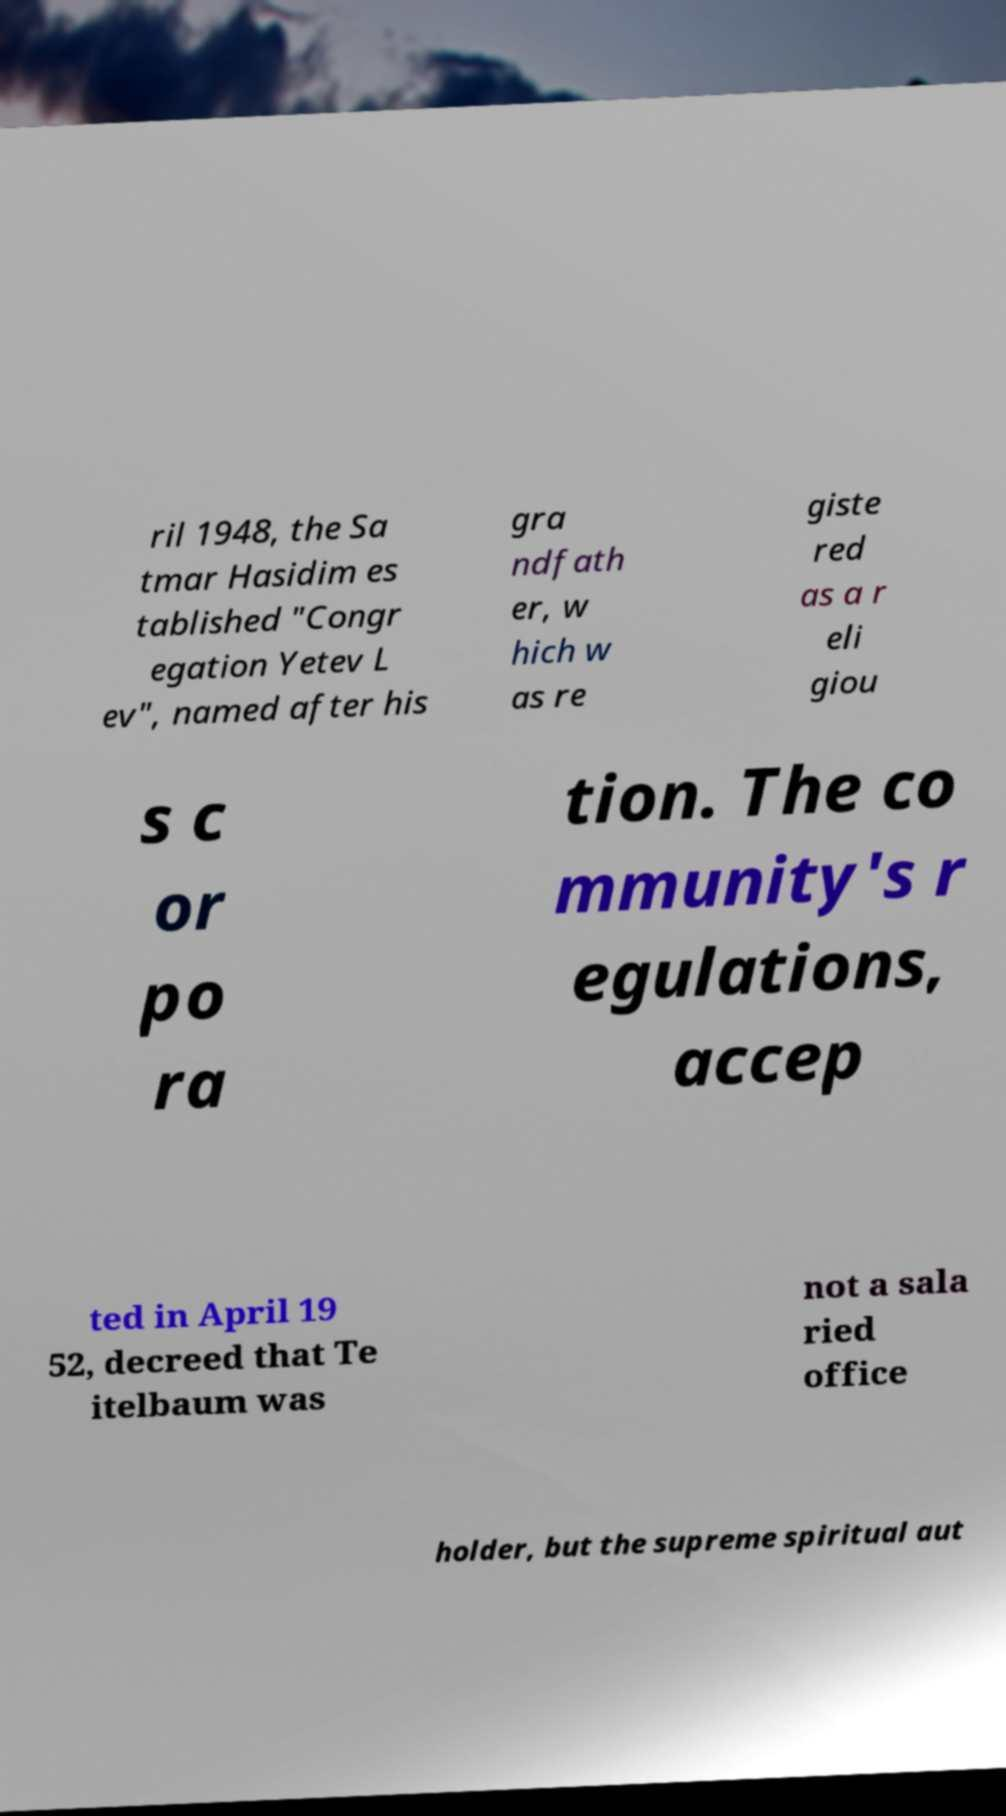For documentation purposes, I need the text within this image transcribed. Could you provide that? ril 1948, the Sa tmar Hasidim es tablished "Congr egation Yetev L ev", named after his gra ndfath er, w hich w as re giste red as a r eli giou s c or po ra tion. The co mmunity's r egulations, accep ted in April 19 52, decreed that Te itelbaum was not a sala ried office holder, but the supreme spiritual aut 